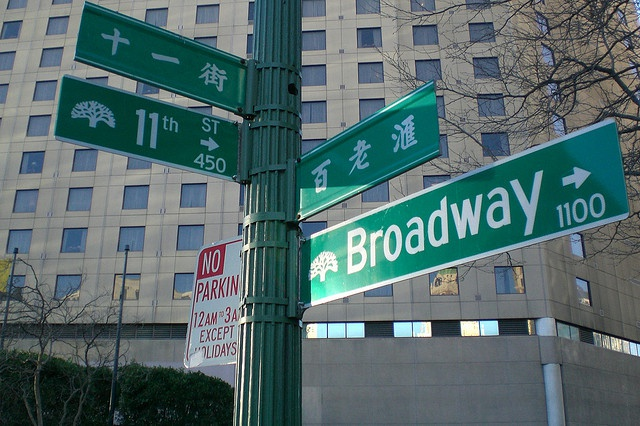Describe the objects in this image and their specific colors. I can see various objects in this image with different colors. 